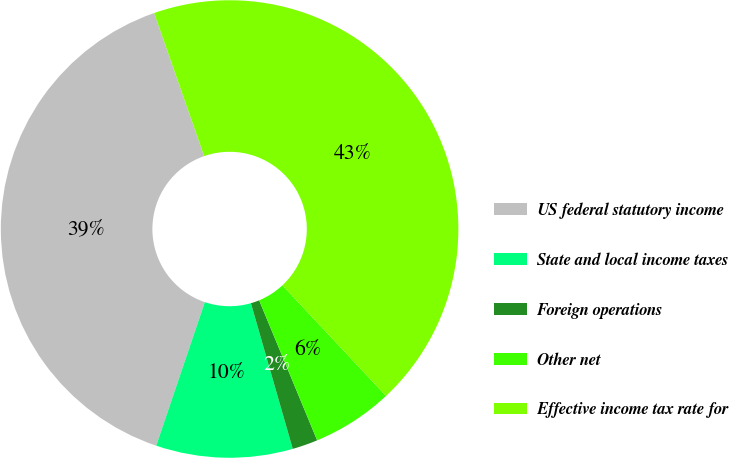<chart> <loc_0><loc_0><loc_500><loc_500><pie_chart><fcel>US federal statutory income<fcel>State and local income taxes<fcel>Foreign operations<fcel>Other net<fcel>Effective income tax rate for<nl><fcel>39.45%<fcel>9.65%<fcel>1.8%<fcel>5.73%<fcel>43.37%<nl></chart> 